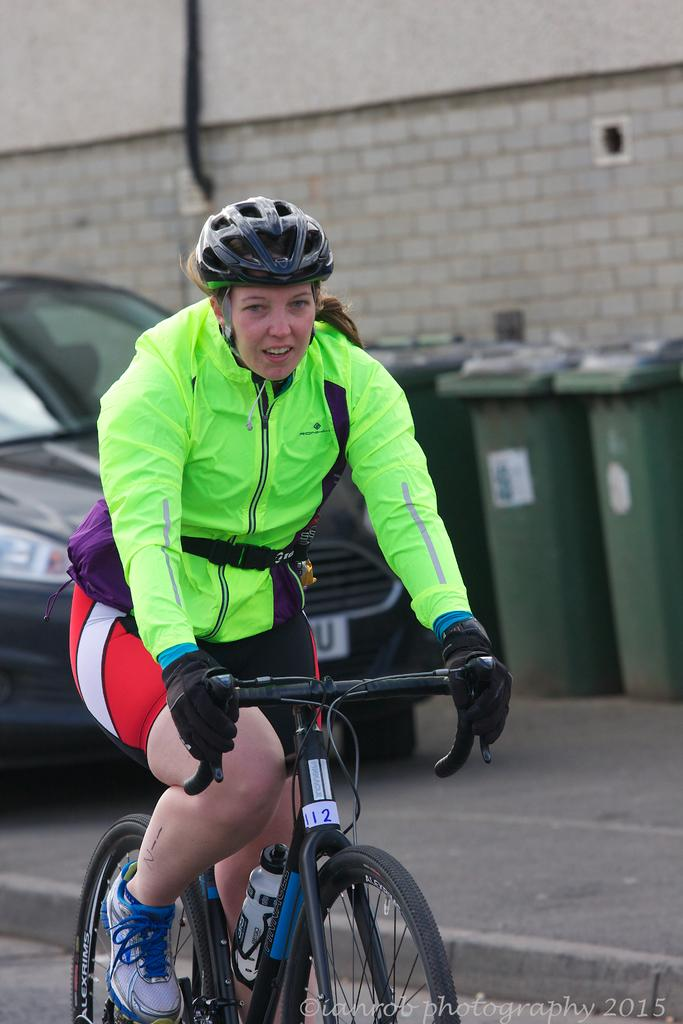Who is the main subject in the image? There is a woman in the image. What is the woman doing in the image? The woman is riding a bicycle. What is the woman wearing in the image? The woman is wearing a green jacket, trousers, shoes, and a helmet. What can be seen in the background of the image? There is a car, three dustbins, and a wall in the background of the image. What trick is the queen performing in the image? There is no queen or trick present in the image; it features a woman riding a bicycle. What story does the image tell about the woman's journey? The image does not tell a story about the woman's journey; it simply shows her riding a bicycle. 